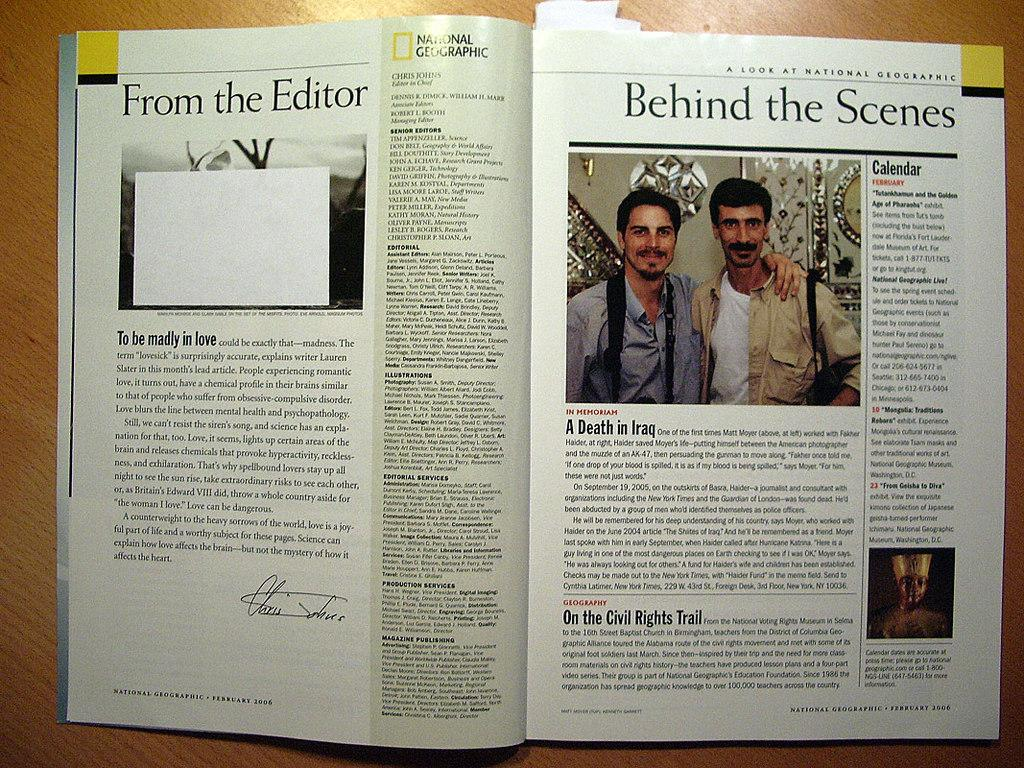<image>
Relay a brief, clear account of the picture shown. A National Geographic Magazine open to a page titled From the Editor. 